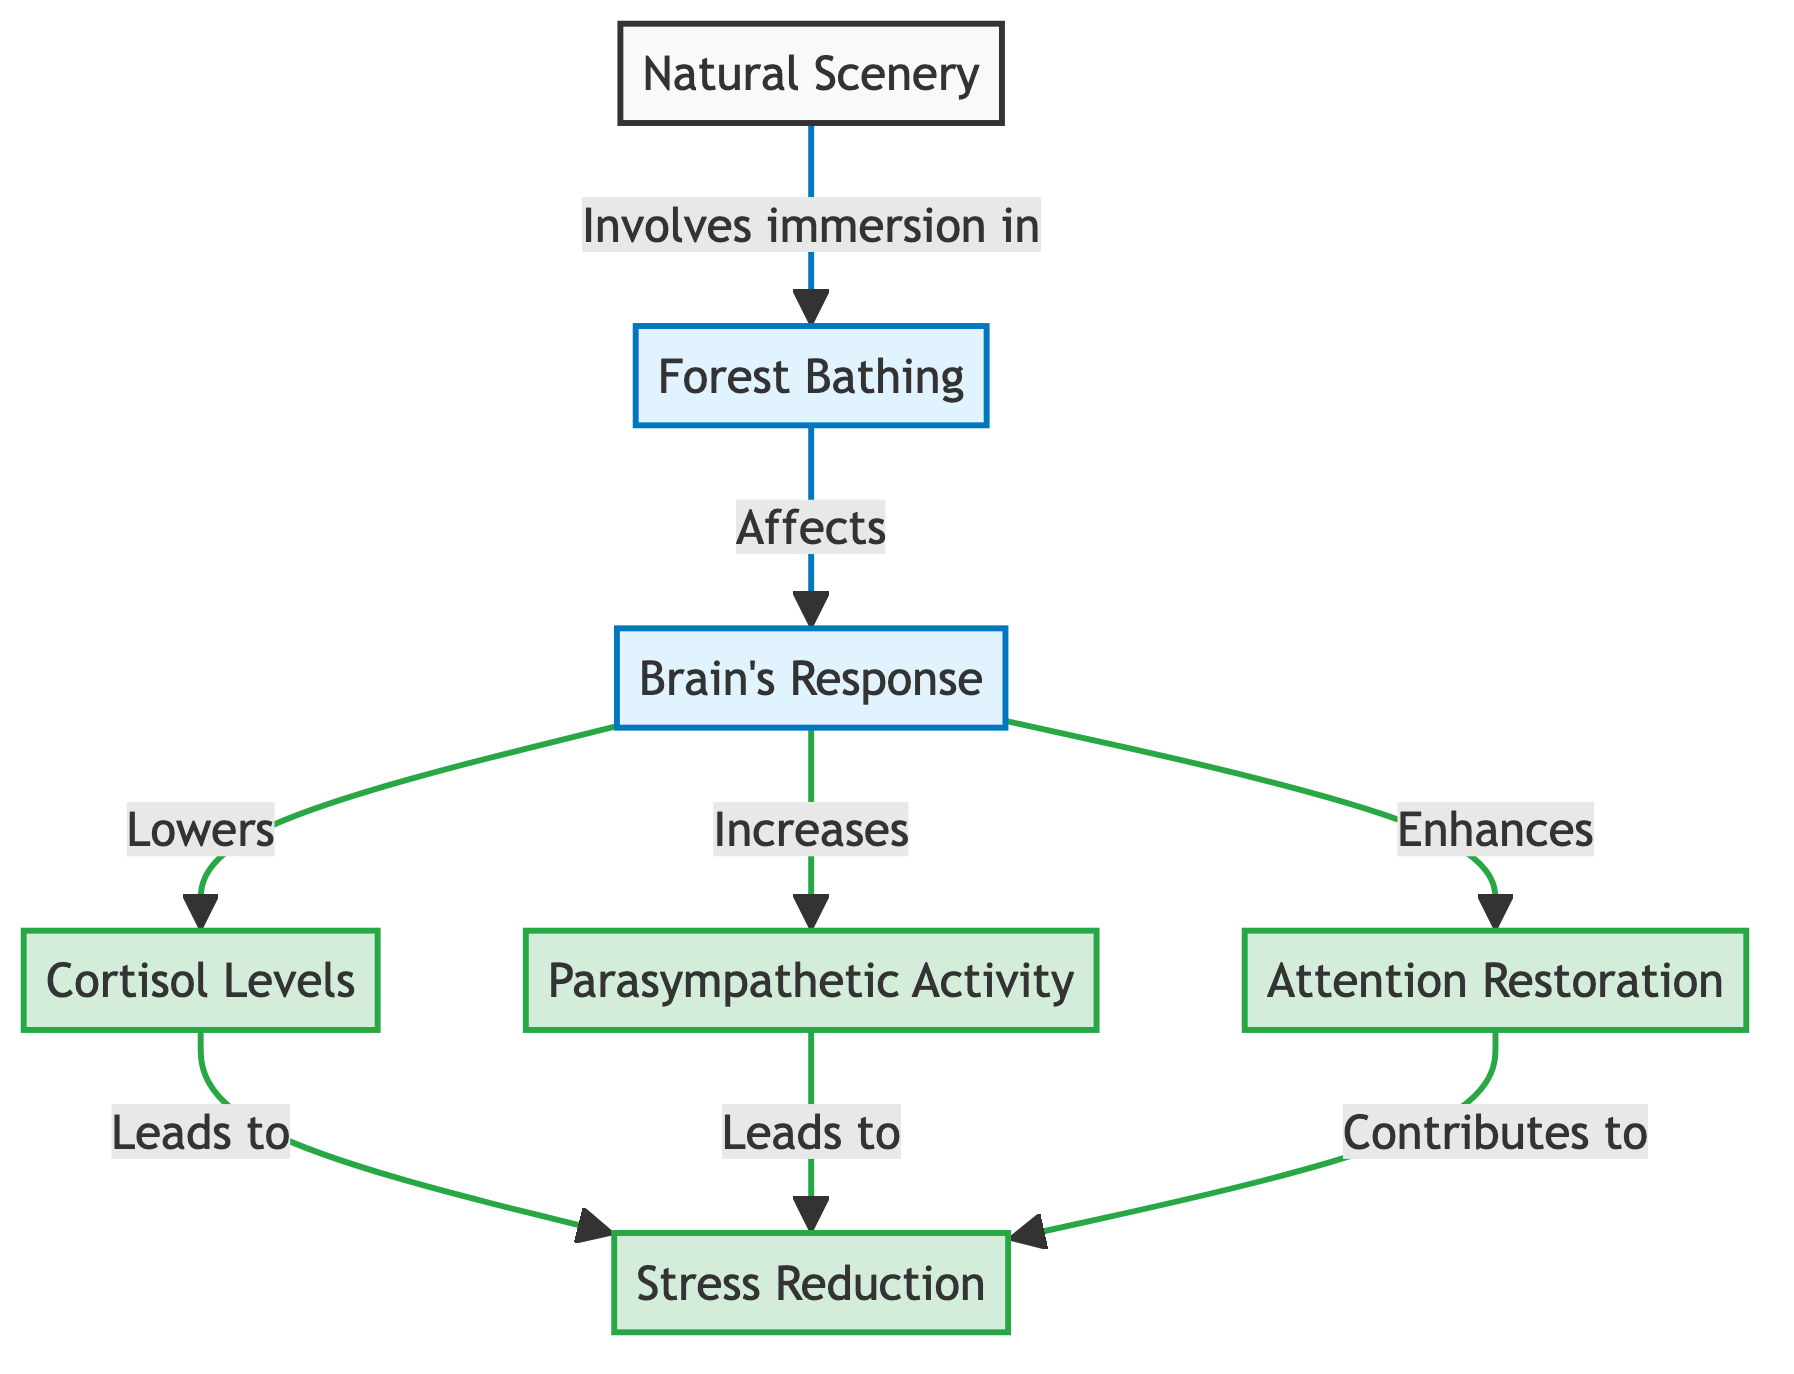What is the starting point of the diagram? The starting point of the diagram is "Natural Scenery," which is the initial node that initiates the flow towards "Forest Bathing."
Answer: Natural Scenery How many outcomes are identified in the diagram? The diagram lists three outcomes resulting from the brain's response: "Cortisol Levels," "Parasympathetic Activity," and "Attention Restoration." Therefore, there are three outcomes.
Answer: Three What increases as a result of "Brain's Response"? The diagram shows "Parasympathetic Activity" as something that increases as a direct result of the brain's response to forest bathing.
Answer: Parasympathetic Activity Which element contributes to stress reduction? Both "Parasympathetic Activity" and "Attention Restoration" are shown to contribute to stress reduction in the diagram.
Answer: Parasympathetic Activity and Attention Restoration How does "Forest Bathing" affect "Cortisol Levels"? The diagram indicates that "Forest Bathing" affects "Cortisol Levels" by lowering them, establishing a direct relationship between these two nodes.
Answer: Lowers What is the relationship between "Cortisol Levels" and "Stress Reduction"? According to the diagram, "Cortisol Levels" leads to "Stress Reduction," meaning that changes in cortisol levels directly impact stress levels.
Answer: Leads to What does "Attention Restoration" directly enhance? The diagram states that "Attention Restoration" is enhanced as a part of the brain's response to "Forest Bathing."
Answer: Attention Restoration Which process is positioned as the main intervention in the diagram? The main intervention depicted in the diagram is "Forest Bathing," which initiates the effects on the brain's response and subsequent outcomes.
Answer: Forest Bathing What is the last outcome in the flow? The last outcome in the flow of the diagram is "Stress Reduction," which results from the effects of lowered cortisol levels, increased parasympathetic activity, and enhanced attention restoration.
Answer: Stress Reduction 